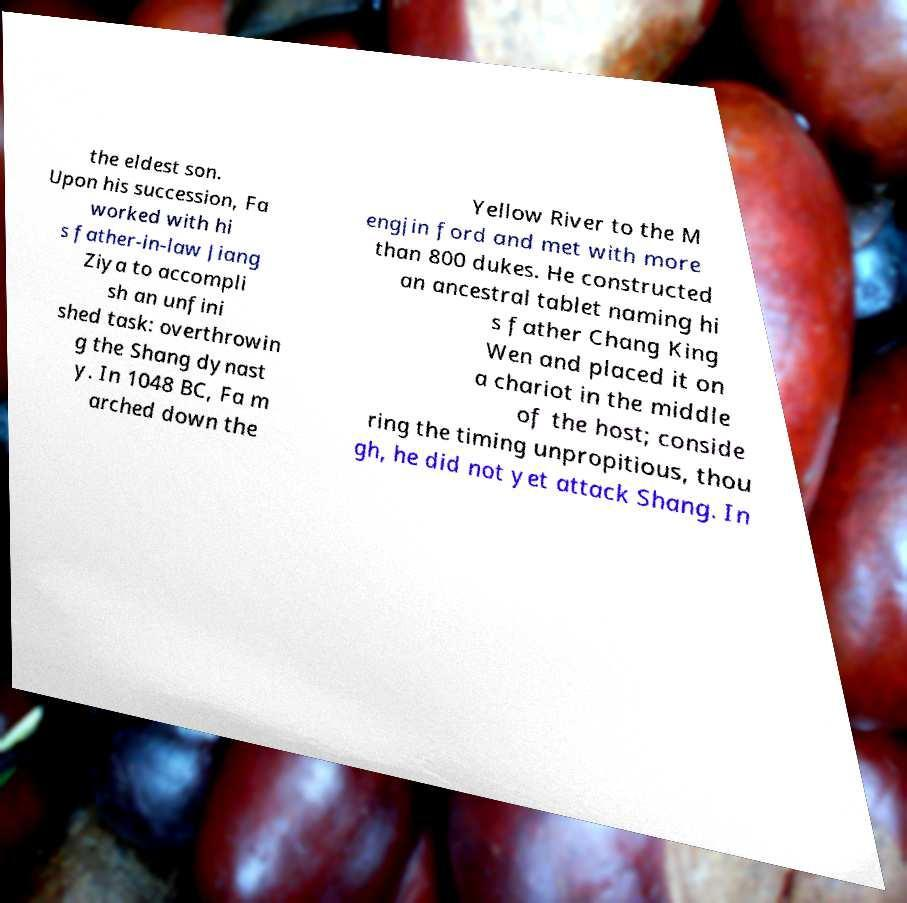There's text embedded in this image that I need extracted. Can you transcribe it verbatim? the eldest son. Upon his succession, Fa worked with hi s father-in-law Jiang Ziya to accompli sh an unfini shed task: overthrowin g the Shang dynast y. In 1048 BC, Fa m arched down the Yellow River to the M engjin ford and met with more than 800 dukes. He constructed an ancestral tablet naming hi s father Chang King Wen and placed it on a chariot in the middle of the host; conside ring the timing unpropitious, thou gh, he did not yet attack Shang. In 